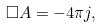<formula> <loc_0><loc_0><loc_500><loc_500>\Box { A } = - 4 \pi { j } ,</formula> 